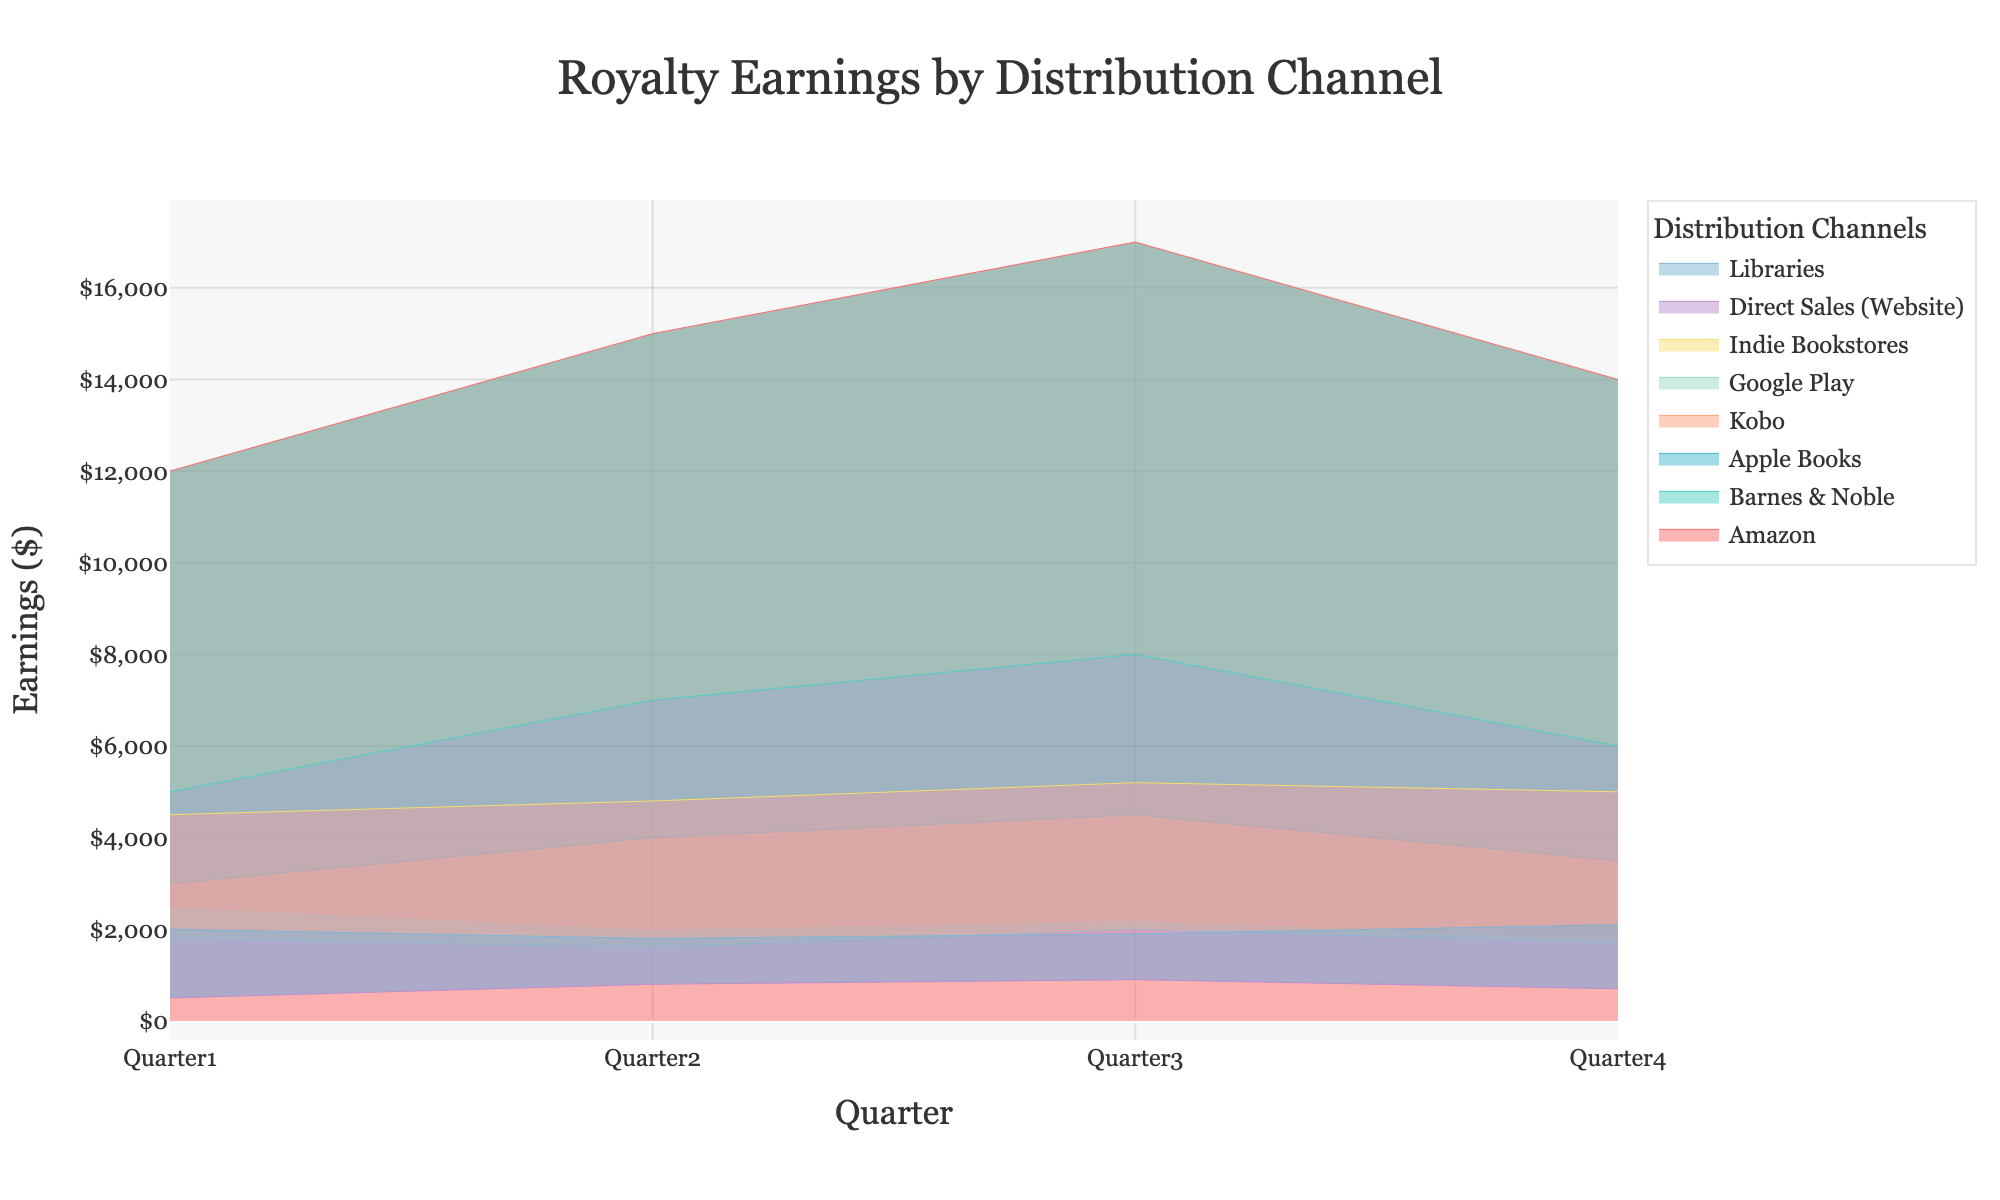What's the title of the figure? The title is displayed at the top of the figure.
Answer: Royalty Earnings by Distribution Channel What is the color of the line for Amazon? The lines are color-coded, Amazon's line color is noticeable in the legend and on the plot itself.
Answer: Red Which distribution channel had the highest earnings in Quarter 3? By comparing the top values for each channel in Quarter 3, the line corresponding to Amazon is at the highest point.
Answer: Amazon What is the total earnings for Indie Bookstores across all quarters? Sum the values for Indie Bookstores: 4500 (Quarter 1) + 4800 (Quarter 2) + 5200 (Quarter 3) + 5000 (Quarter 4).
Answer: $19,500 How did Google's earnings change from Quarter 1 to Quarter 4? Look at the values for Google Play in each quarter: 1800 (Quarter 1), 1600 (Quarter 2), 2000 (Quarter 3), and 1700 (Quarter 4). Calculate the differences.
Answer: Decreased by $100 over the period Which quarter shows the least earnings overall for all distribution channels combined? Add up the earnings for all channels for each quarter and compare the sums.
Answer: Quarter 1 How much higher were Apple's earnings in Quarter 4 compared to Kobo's in the same quarter? Subtract Kobo's earnings for Quarter 4 from Apple Books in the same quarter: 3500 - 1800.
Answer: $1,700 Which distribution channel consistently saw the lowest earnings in each quarter? Compare the earnings of all distribution channels across all quarters to find the lowest values in each one.
Answer: Direct Sales (Website) Between Apple Books and Barnes & Noble, which channel had the better performance overall across all quarters? Sum the quarterly earnings for both channels and compare the totals: Apple Books: 3000 + 4000 + 4500 + 3500, Barnes & Noble: 5000 + 7000 + 8000 + 6000.
Answer: Barnes & Noble Is there any quarter where Kobo's earnings increased compared to the previous quarter? Compare Kobo's earnings in each quarter to see if there is any increase from one quarter to the next: Quarter 1 (2500), Quarter 2 (2000), Quarter 3 (2200), Quarter 4 (1800).
Answer: Yes, between Quarter 2 and Quarter 3 